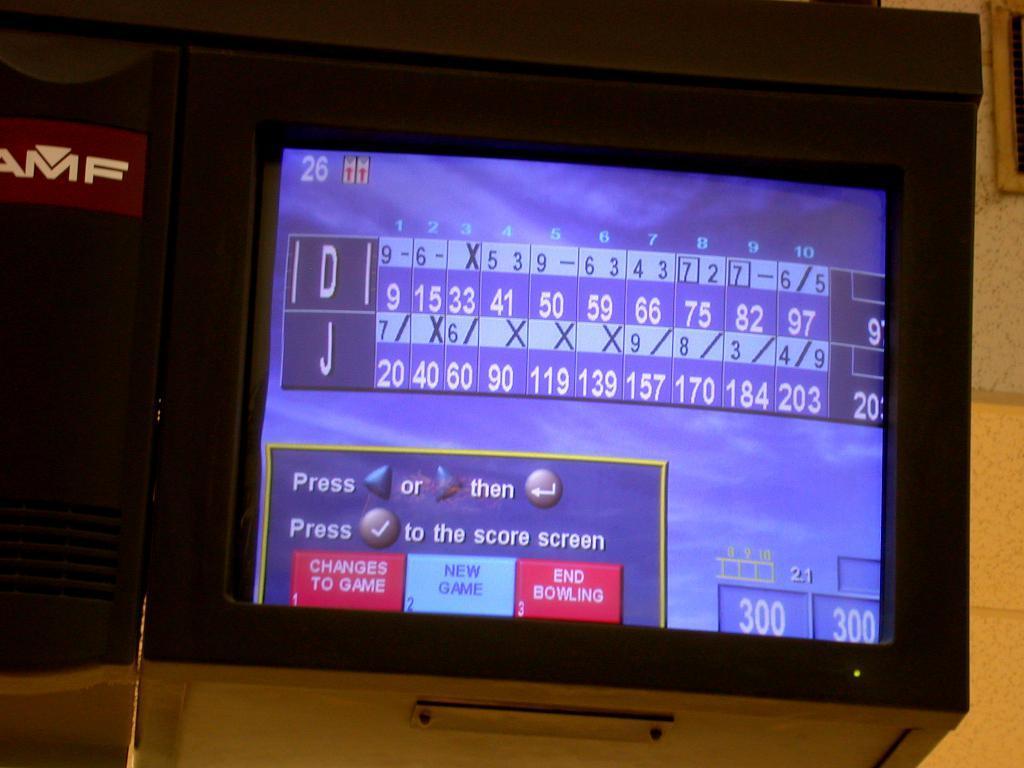Could you give a brief overview of what you see in this image? In this image I can see a screen. I can see a numbers and something is written on it. It is in blue color. 